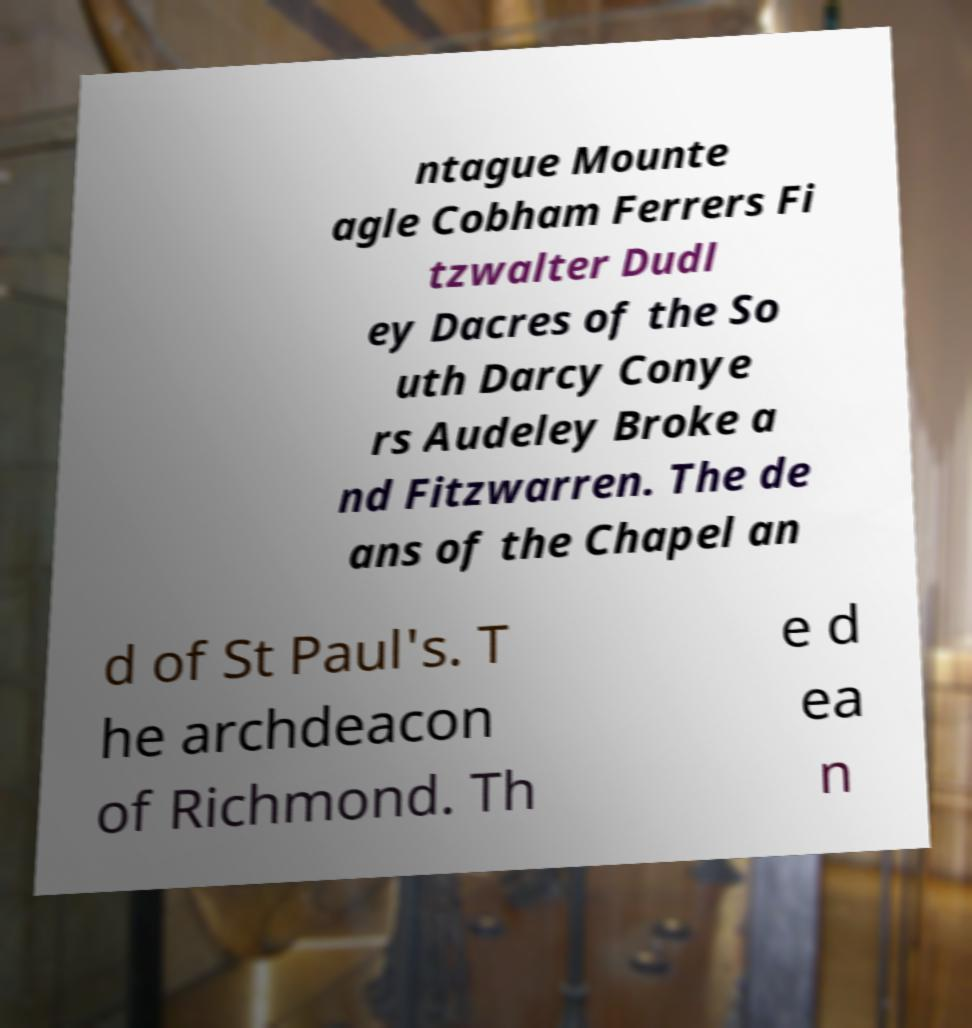There's text embedded in this image that I need extracted. Can you transcribe it verbatim? ntague Mounte agle Cobham Ferrers Fi tzwalter Dudl ey Dacres of the So uth Darcy Conye rs Audeley Broke a nd Fitzwarren. The de ans of the Chapel an d of St Paul's. T he archdeacon of Richmond. Th e d ea n 